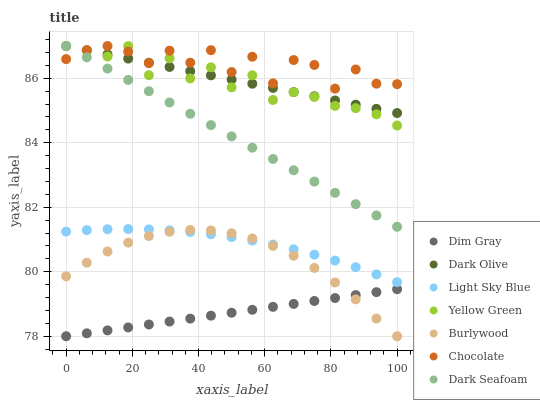Does Dim Gray have the minimum area under the curve?
Answer yes or no. Yes. Does Chocolate have the maximum area under the curve?
Answer yes or no. Yes. Does Yellow Green have the minimum area under the curve?
Answer yes or no. No. Does Yellow Green have the maximum area under the curve?
Answer yes or no. No. Is Dim Gray the smoothest?
Answer yes or no. Yes. Is Chocolate the roughest?
Answer yes or no. Yes. Is Yellow Green the smoothest?
Answer yes or no. No. Is Yellow Green the roughest?
Answer yes or no. No. Does Dim Gray have the lowest value?
Answer yes or no. Yes. Does Yellow Green have the lowest value?
Answer yes or no. No. Does Dark Seafoam have the highest value?
Answer yes or no. Yes. Does Burlywood have the highest value?
Answer yes or no. No. Is Burlywood less than Yellow Green?
Answer yes or no. Yes. Is Dark Seafoam greater than Burlywood?
Answer yes or no. Yes. Does Chocolate intersect Dark Olive?
Answer yes or no. Yes. Is Chocolate less than Dark Olive?
Answer yes or no. No. Is Chocolate greater than Dark Olive?
Answer yes or no. No. Does Burlywood intersect Yellow Green?
Answer yes or no. No. 